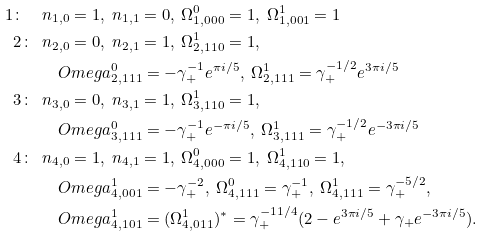<formula> <loc_0><loc_0><loc_500><loc_500>1 \colon \ \ & n _ { 1 , 0 } = 1 , \ n _ { 1 , 1 } = 0 , \ \Omega ^ { 0 } _ { 1 , 0 0 0 } = 1 , \ \Omega ^ { 1 } _ { 1 , 0 0 1 } = 1 \\ 2 \colon \ \ & n _ { 2 , 0 } = 0 , \ n _ { 2 , 1 } = 1 , \ \Omega ^ { 1 } _ { 2 , 1 1 0 } = 1 , \\ & \quad O m e g a ^ { 0 } _ { 2 , 1 1 1 } = - \gamma _ { + } ^ { - 1 } e ^ { \pi i / 5 } , \ \Omega ^ { 1 } _ { 2 , 1 1 1 } = \gamma _ { + } ^ { - 1 / 2 } e ^ { 3 \pi i / 5 } \\ 3 \colon \ \ & n _ { 3 , 0 } = 0 , \ n _ { 3 , 1 } = 1 , \ \Omega ^ { 1 } _ { 3 , 1 1 0 } = 1 , \\ & \quad O m e g a ^ { 0 } _ { 3 , 1 1 1 } = - \gamma _ { + } ^ { - 1 } e ^ { - \pi i / 5 } , \ \Omega ^ { 1 } _ { 3 , 1 1 1 } = \gamma _ { + } ^ { - 1 / 2 } e ^ { - 3 \pi i / 5 } \\ 4 \colon \ \ & n _ { 4 , 0 } = 1 , \ n _ { 4 , 1 } = 1 , \ \Omega ^ { 0 } _ { 4 , 0 0 0 } = 1 , \ \Omega ^ { 1 } _ { 4 , 1 1 0 } = 1 , \\ & \quad O m e g a ^ { 1 } _ { 4 , 0 0 1 } = - \gamma _ { + } ^ { - 2 } , \ \Omega ^ { 0 } _ { 4 , 1 1 1 } = \gamma _ { + } ^ { - 1 } , \ \Omega ^ { 1 } _ { 4 , 1 1 1 } = \gamma _ { + } ^ { - 5 / 2 } , \\ & \quad O m e g a ^ { 1 } _ { 4 , 1 0 1 } = ( \Omega ^ { 1 } _ { 4 , 0 1 1 } ) ^ { * } = \gamma _ { + } ^ { - 1 1 / 4 } ( 2 - e ^ { 3 \pi i / 5 } + \gamma _ { + } e ^ { - 3 \pi i / 5 } ) .</formula> 